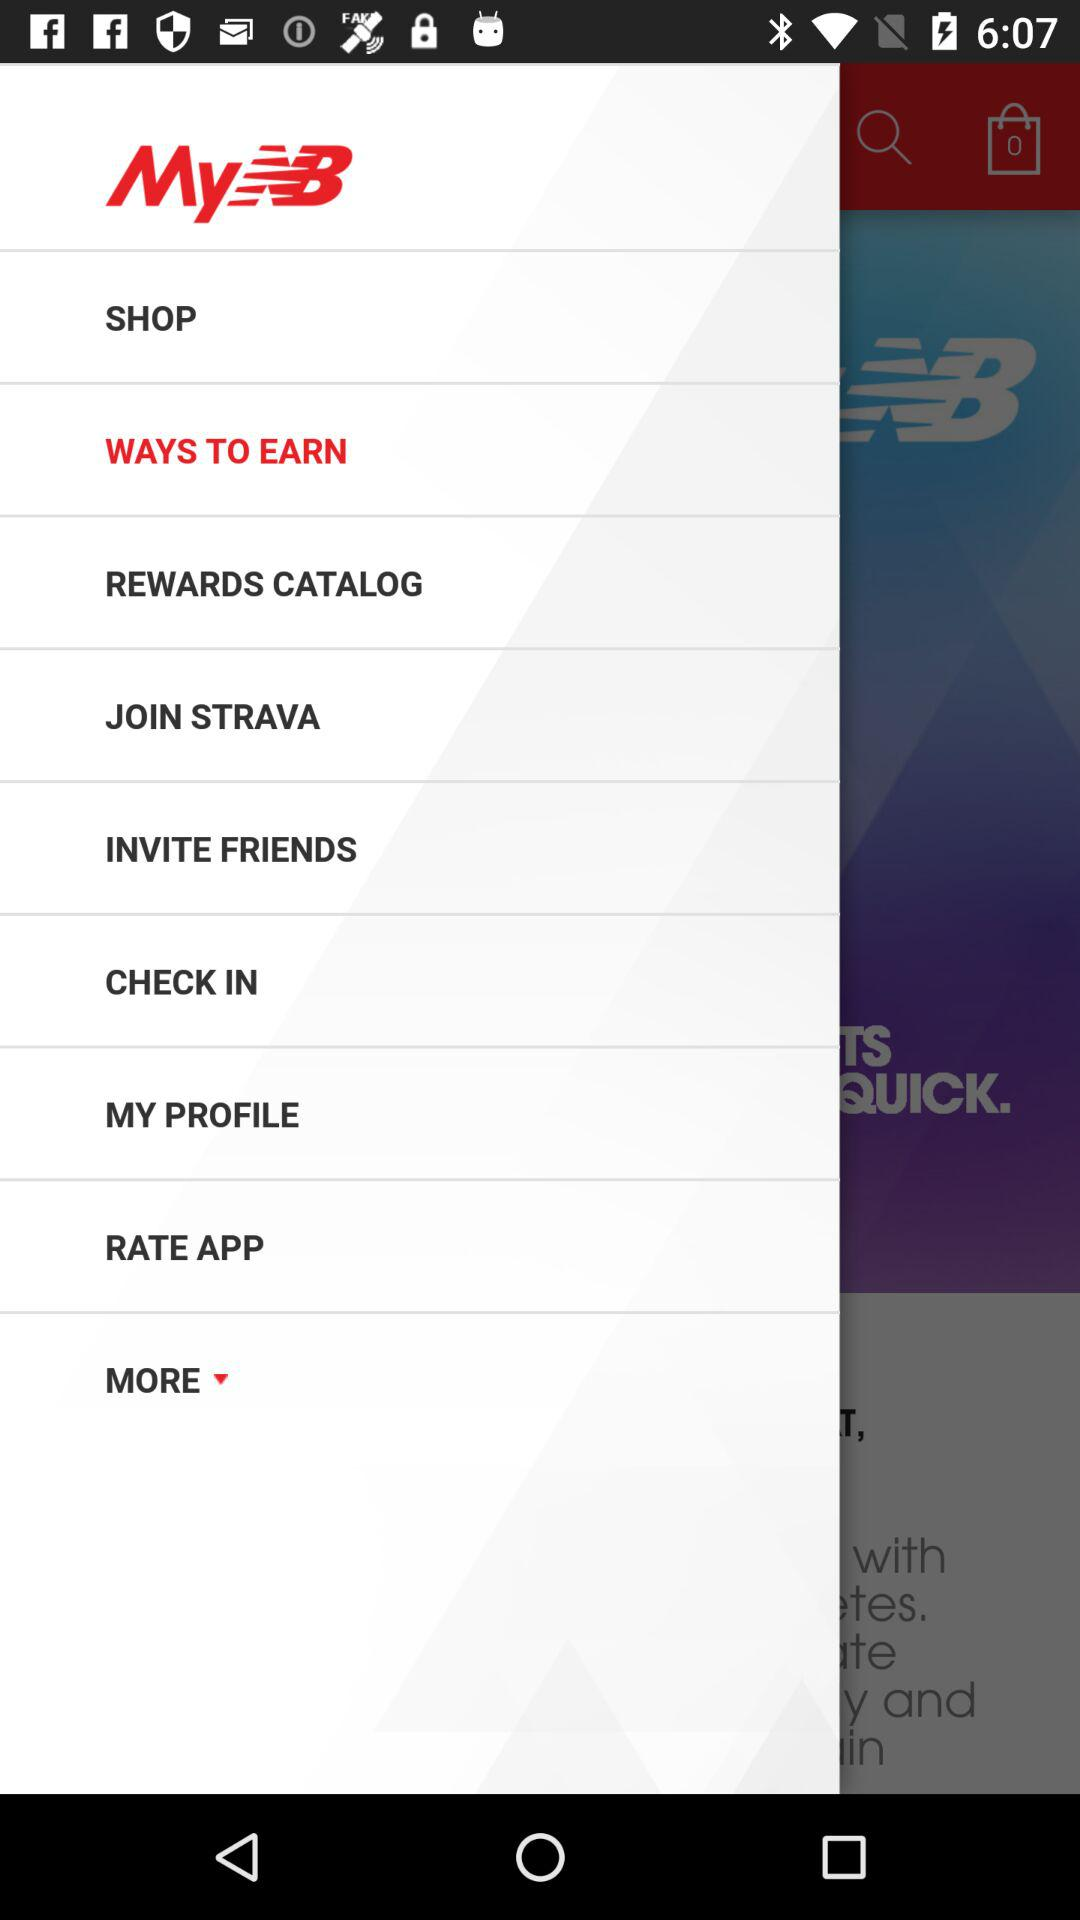What is the application name? The application name is "MyNB". 